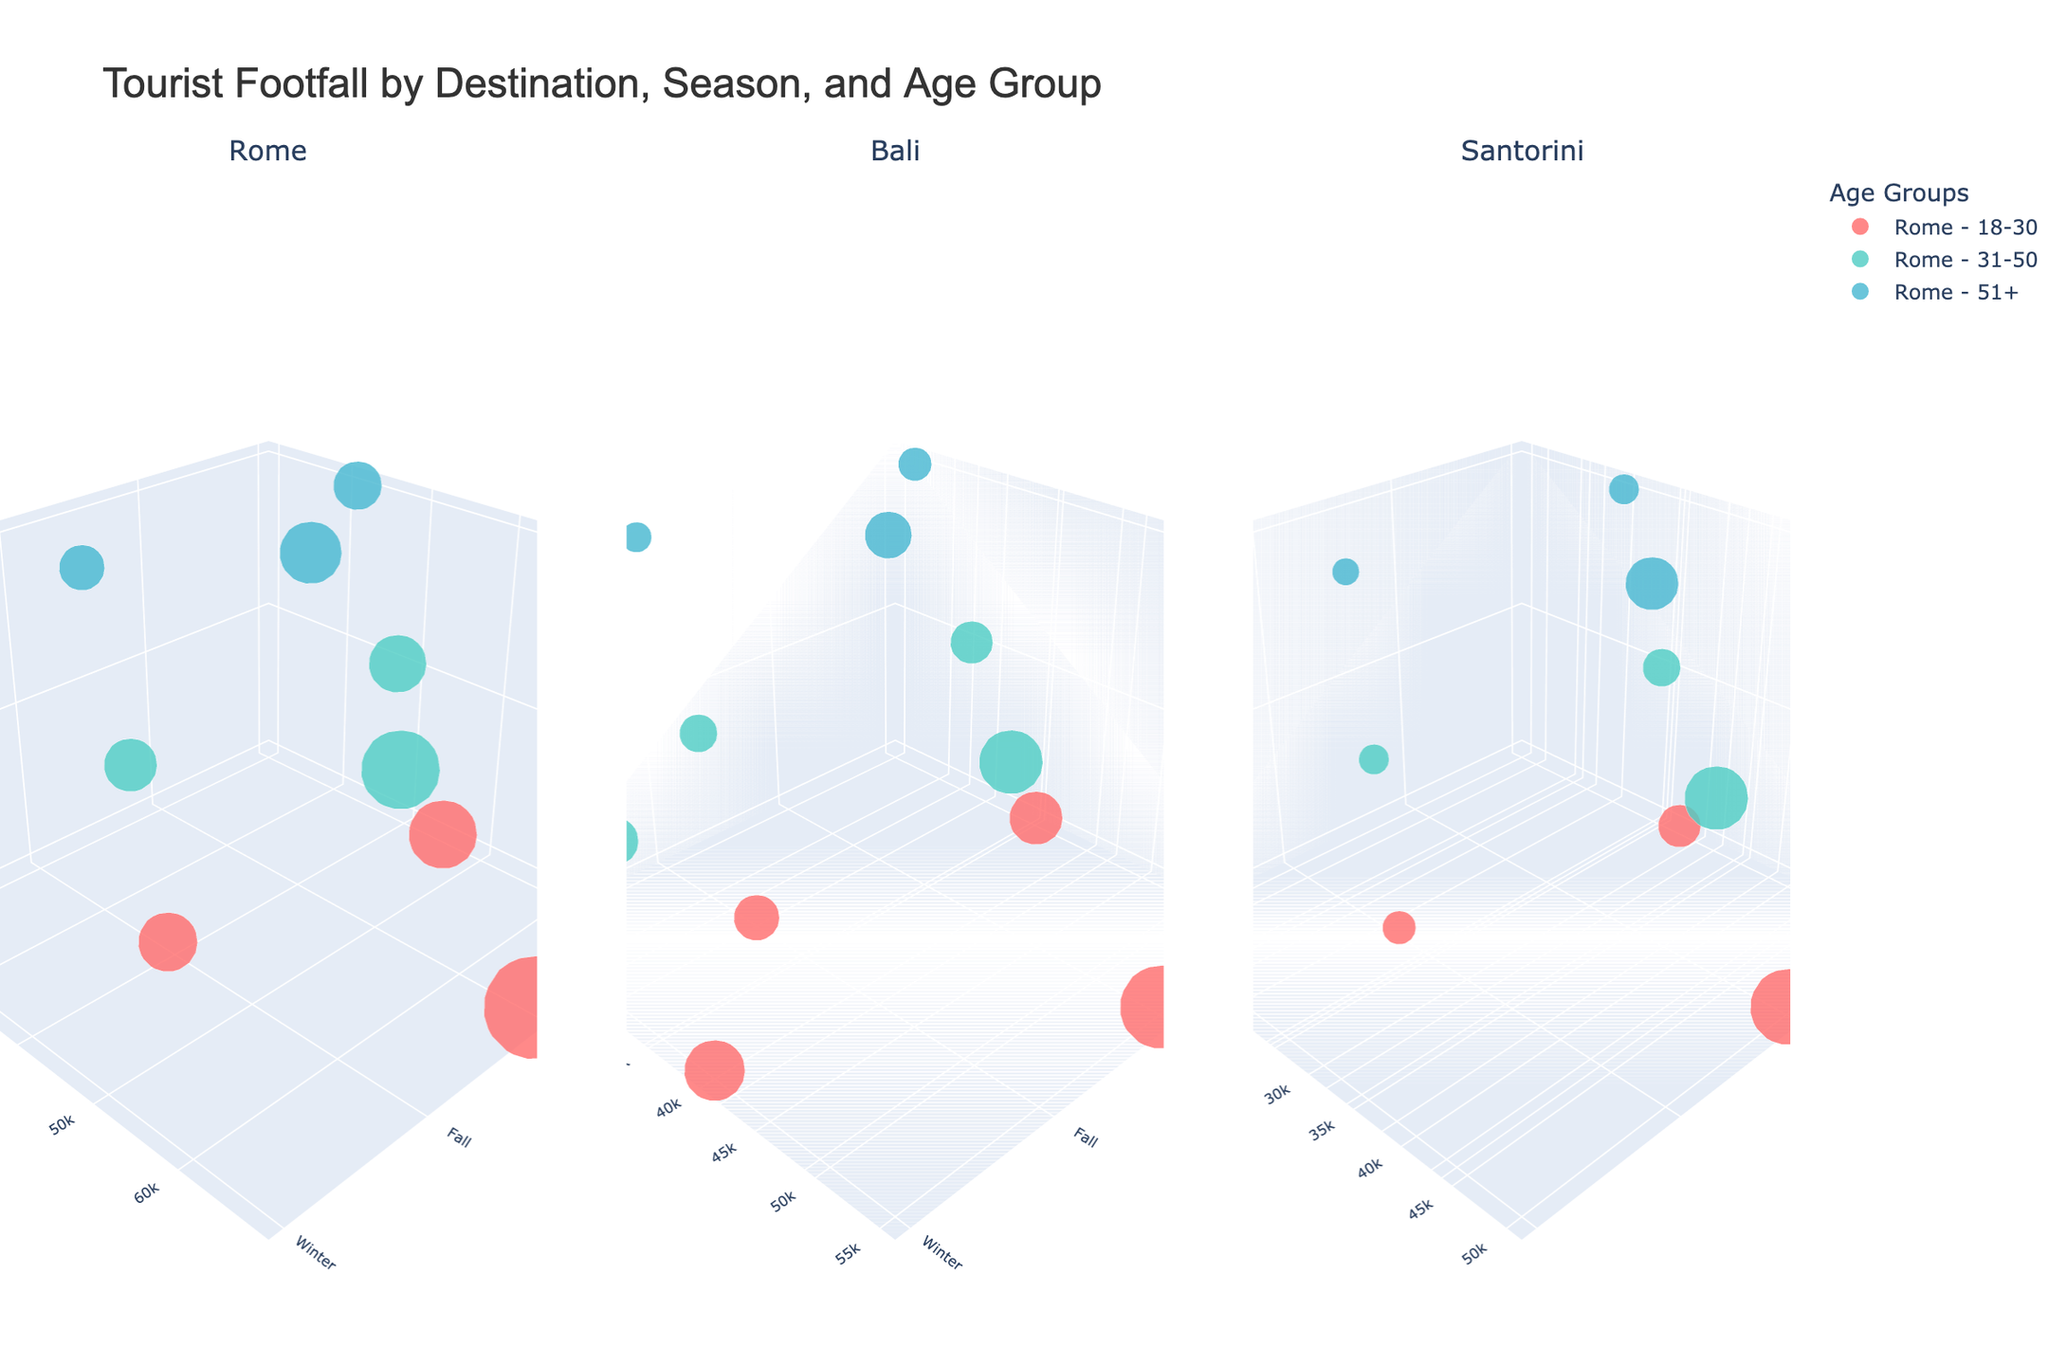What is the title of the plot? The title is usually located at the top of the plot, and in this case, it states the main focus of the plot which is "Tourist Footfall by Destination, Season, and Age Group."
Answer: Tourist Footfall by Destination, Season, and Age Group In which season does Rome receive the highest number of tourists aged 18-30? To determine this, look at the subplot for Rome, and locate the data points corresponding to the 18-30 age group in each season. The highest value is observed in the summer season.
Answer: Summer Which destination has the lowest number of tourists aged 51+ in winter? By examining the winter section for tourists aged 51+ across all three subplots, it is clear that Santorini has the lowest number of tourists.
Answer: Santorini What is the total number of tourists visiting Bali across all seasons for the age group 31-50? Sum the tourist numbers for Bali's 31-50 age group across all seasons: 28000 (Spring) + 42000 (Summer) + 25000 (Fall) + 32000 (Winter) = 127000
Answer: 127000 Compare the number of tourists aged 18-30 in Spring between Santorini and Rome. Which destination has more tourists? Look at the Spring data points for Rome and Santorini for the 18-30 age group. Rome has 45000 tourists, while Santorini has 28000 tourists. Therefore, Rome has more tourists.
Answer: Rome Which age group has the smallest size marker for Santorini in Fall? The marker size is proportional to the number of tourists. For Santorini in Fall, the smallest size marker corresponds to the age group 51+ with 18000 tourists.
Answer: 51+ How does the number of tourists in Bali in Summer compare to Rome in Summer for the age group 18-30? For the age group 18-30, the number of tourists in Bali in Summer is 55000, whereas in Rome it is 68000. Rome has more tourists than Bali in Summer.
Answer: Rome Which season sees the highest tourist footfall in Santorini for the age group 31-50? By examining Santorini's 31-50 age group across all seasons, the highest tourist footfall is observed in Summer with 42000 tourists.
Answer: Summer How many total tourists visit Santorini in Winter across all age groups? Sum the tourist numbers for Santorini in Winter across all age groups: 12000 (18-30) + 10000 (31-50) + 8000 (51+) = 30000
Answer: 30000 Which destination attracts the most tourists aged 51+ during Fall? By examining the fall section across all three subplots for the 51+ age group, Rome attracts the most tourists with 30000.
Answer: Rome 